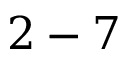<formula> <loc_0><loc_0><loc_500><loc_500>2 - 7</formula> 